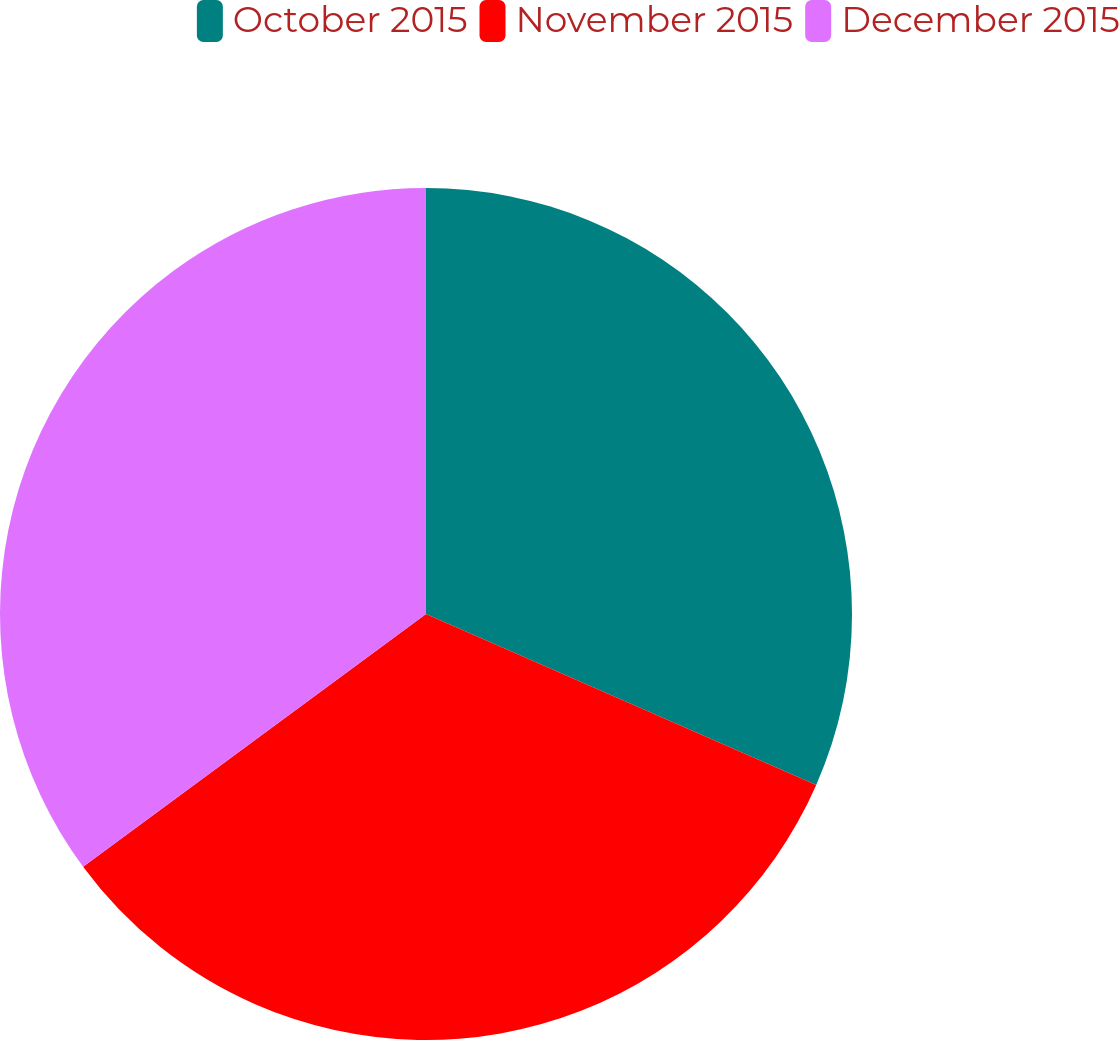Convert chart to OTSL. <chart><loc_0><loc_0><loc_500><loc_500><pie_chart><fcel>October 2015<fcel>November 2015<fcel>December 2015<nl><fcel>31.57%<fcel>33.32%<fcel>35.11%<nl></chart> 